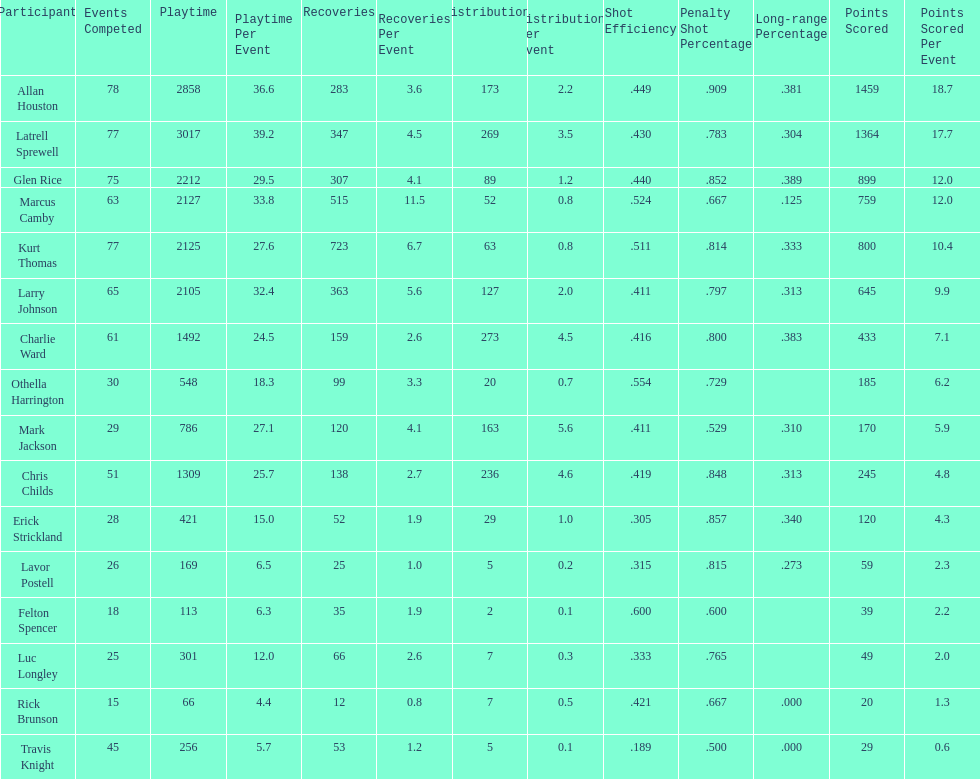Who scored more points, larry johnson or charlie ward? Larry Johnson. 